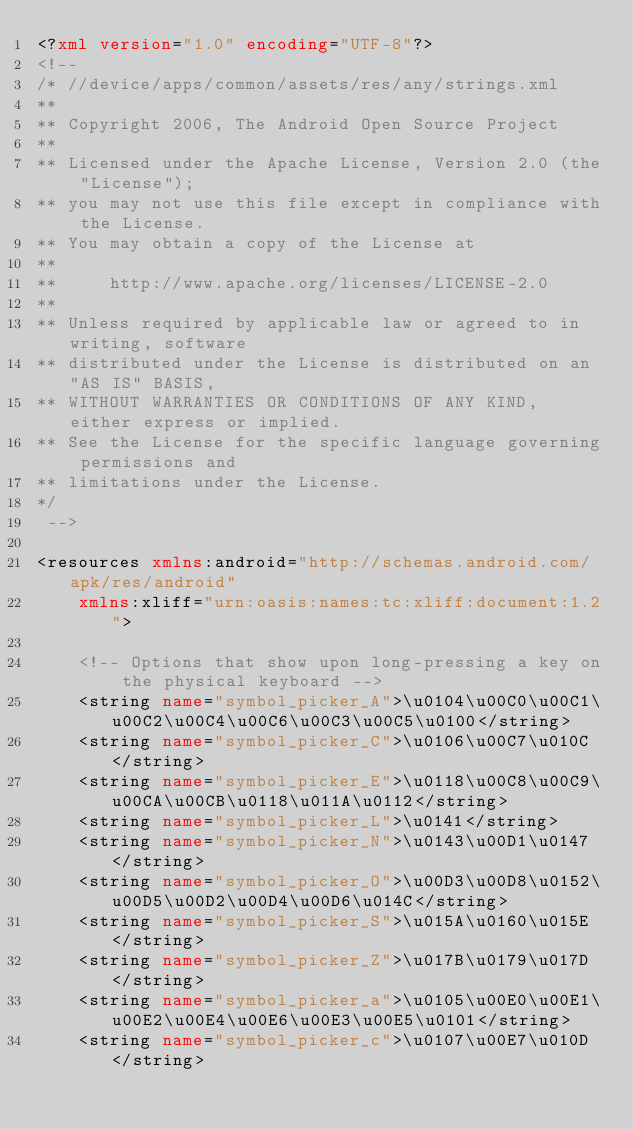Convert code to text. <code><loc_0><loc_0><loc_500><loc_500><_XML_><?xml version="1.0" encoding="UTF-8"?>
<!-- 
/* //device/apps/common/assets/res/any/strings.xml
**
** Copyright 2006, The Android Open Source Project
**
** Licensed under the Apache License, Version 2.0 (the "License");
** you may not use this file except in compliance with the License.
** You may obtain a copy of the License at
**
**     http://www.apache.org/licenses/LICENSE-2.0
**
** Unless required by applicable law or agreed to in writing, software
** distributed under the License is distributed on an "AS IS" BASIS,
** WITHOUT WARRANTIES OR CONDITIONS OF ANY KIND, either express or implied.
** See the License for the specific language governing permissions and
** limitations under the License.
*/
 -->

<resources xmlns:android="http://schemas.android.com/apk/res/android"
    xmlns:xliff="urn:oasis:names:tc:xliff:document:1.2">

    <!-- Options that show upon long-pressing a key on the physical keyboard -->
    <string name="symbol_picker_A">\u0104\u00C0\u00C1\u00C2\u00C4\u00C6\u00C3\u00C5\u0100</string>
    <string name="symbol_picker_C">\u0106\u00C7\u010C</string>
    <string name="symbol_picker_E">\u0118\u00C8\u00C9\u00CA\u00CB\u0118\u011A\u0112</string>
    <string name="symbol_picker_L">\u0141</string>
    <string name="symbol_picker_N">\u0143\u00D1\u0147</string>
    <string name="symbol_picker_O">\u00D3\u00D8\u0152\u00D5\u00D2\u00D4\u00D6\u014C</string>
    <string name="symbol_picker_S">\u015A\u0160\u015E</string>
    <string name="symbol_picker_Z">\u017B\u0179\u017D</string>
    <string name="symbol_picker_a">\u0105\u00E0\u00E1\u00E2\u00E4\u00E6\u00E3\u00E5\u0101</string>
    <string name="symbol_picker_c">\u0107\u00E7\u010D</string></code> 